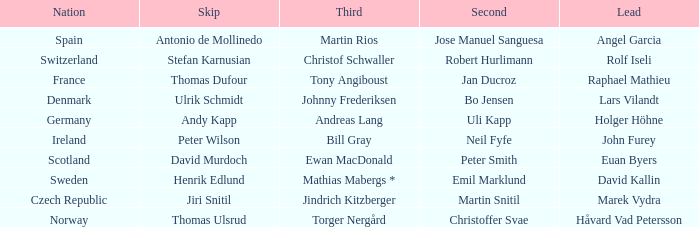When did France come in second? Jan Ducroz. 